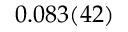<formula> <loc_0><loc_0><loc_500><loc_500>0 . 0 8 3 ( 4 2 )</formula> 